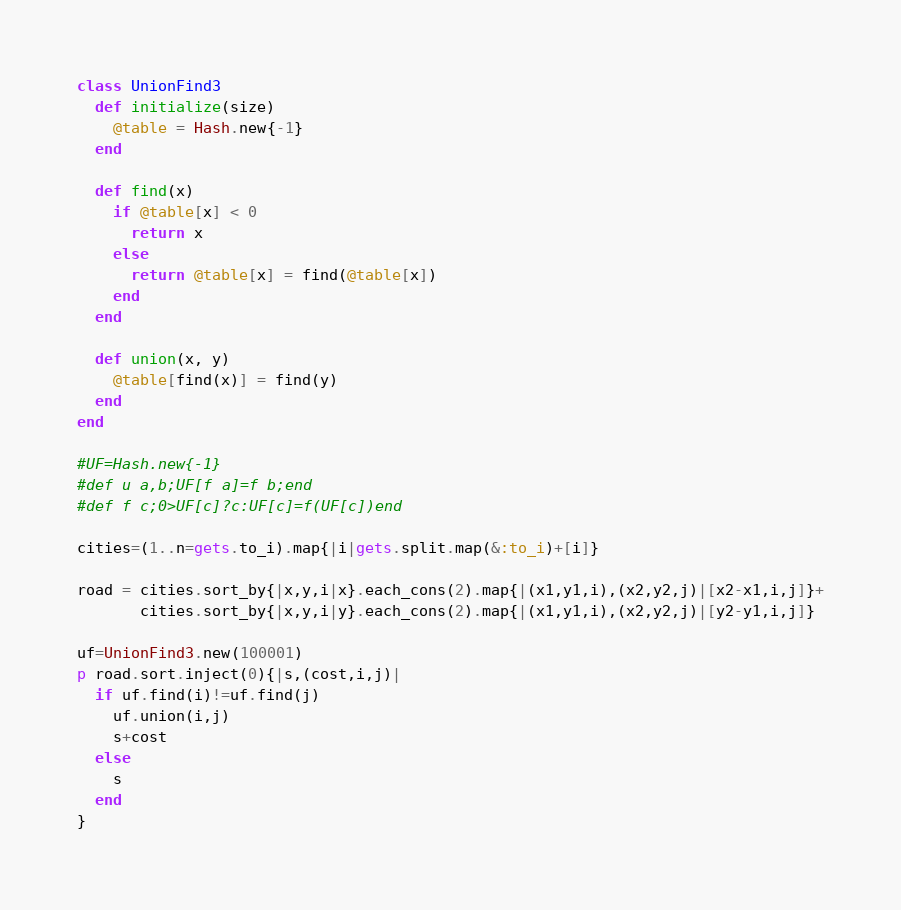<code> <loc_0><loc_0><loc_500><loc_500><_Ruby_>class UnionFind3
  def initialize(size)
    @table = Hash.new{-1}
  end

  def find(x)
    if @table[x] < 0
      return x
    else
      return @table[x] = find(@table[x])
    end
  end

  def union(x, y)
    @table[find(x)] = find(y)
  end
end

#UF=Hash.new{-1}
#def u a,b;UF[f a]=f b;end
#def f c;0>UF[c]?c:UF[c]=f(UF[c])end

cities=(1..n=gets.to_i).map{|i|gets.split.map(&:to_i)+[i]}

road = cities.sort_by{|x,y,i|x}.each_cons(2).map{|(x1,y1,i),(x2,y2,j)|[x2-x1,i,j]}+
       cities.sort_by{|x,y,i|y}.each_cons(2).map{|(x1,y1,i),(x2,y2,j)|[y2-y1,i,j]}

uf=UnionFind3.new(100001)
p road.sort.inject(0){|s,(cost,i,j)|
  if uf.find(i)!=uf.find(j)
    uf.union(i,j)
    s+cost
  else
    s
  end
}
</code> 